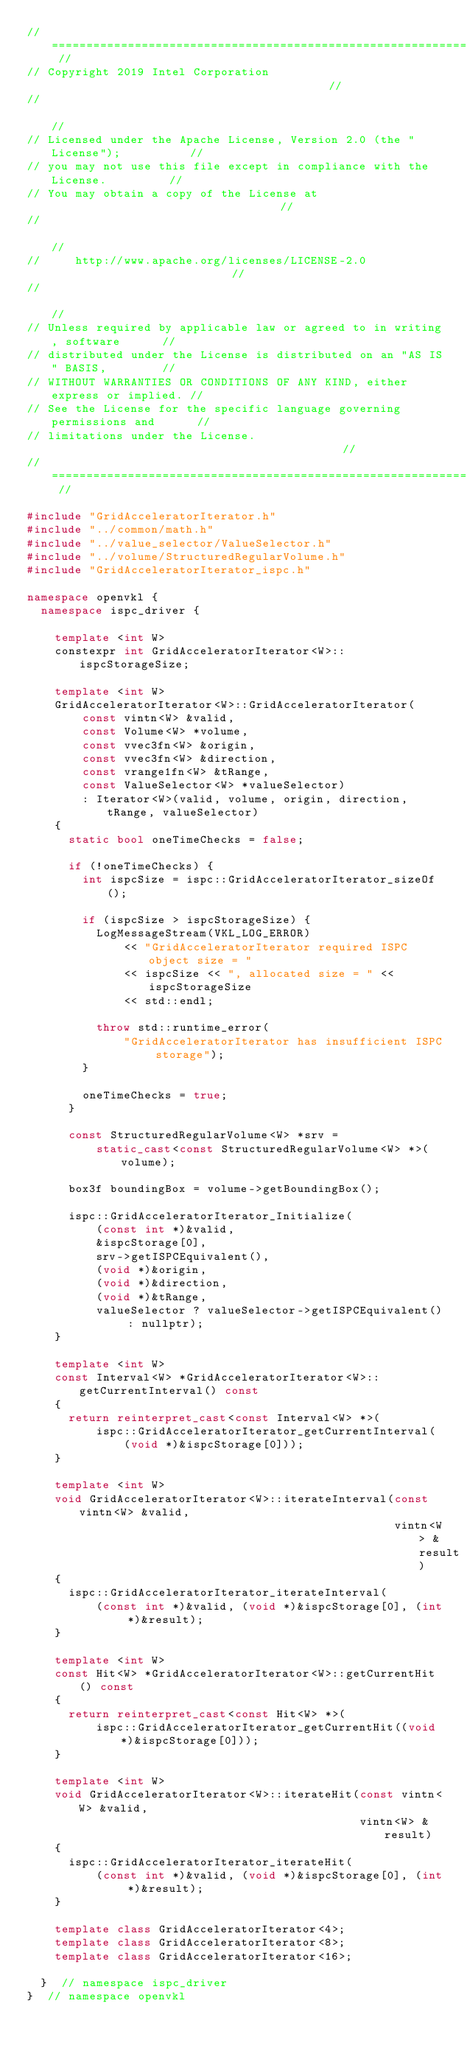<code> <loc_0><loc_0><loc_500><loc_500><_C++_>// ======================================================================== //
// Copyright 2019 Intel Corporation                                         //
//                                                                          //
// Licensed under the Apache License, Version 2.0 (the "License");          //
// you may not use this file except in compliance with the License.         //
// You may obtain a copy of the License at                                  //
//                                                                          //
//     http://www.apache.org/licenses/LICENSE-2.0                           //
//                                                                          //
// Unless required by applicable law or agreed to in writing, software      //
// distributed under the License is distributed on an "AS IS" BASIS,        //
// WITHOUT WARRANTIES OR CONDITIONS OF ANY KIND, either express or implied. //
// See the License for the specific language governing permissions and      //
// limitations under the License.                                           //
// ======================================================================== //

#include "GridAcceleratorIterator.h"
#include "../common/math.h"
#include "../value_selector/ValueSelector.h"
#include "../volume/StructuredRegularVolume.h"
#include "GridAcceleratorIterator_ispc.h"

namespace openvkl {
  namespace ispc_driver {

    template <int W>
    constexpr int GridAcceleratorIterator<W>::ispcStorageSize;

    template <int W>
    GridAcceleratorIterator<W>::GridAcceleratorIterator(
        const vintn<W> &valid,
        const Volume<W> *volume,
        const vvec3fn<W> &origin,
        const vvec3fn<W> &direction,
        const vrange1fn<W> &tRange,
        const ValueSelector<W> *valueSelector)
        : Iterator<W>(valid, volume, origin, direction, tRange, valueSelector)
    {
      static bool oneTimeChecks = false;

      if (!oneTimeChecks) {
        int ispcSize = ispc::GridAcceleratorIterator_sizeOf();

        if (ispcSize > ispcStorageSize) {
          LogMessageStream(VKL_LOG_ERROR)
              << "GridAcceleratorIterator required ISPC object size = "
              << ispcSize << ", allocated size = " << ispcStorageSize
              << std::endl;

          throw std::runtime_error(
              "GridAcceleratorIterator has insufficient ISPC storage");
        }

        oneTimeChecks = true;
      }

      const StructuredRegularVolume<W> *srv =
          static_cast<const StructuredRegularVolume<W> *>(volume);

      box3f boundingBox = volume->getBoundingBox();

      ispc::GridAcceleratorIterator_Initialize(
          (const int *)&valid,
          &ispcStorage[0],
          srv->getISPCEquivalent(),
          (void *)&origin,
          (void *)&direction,
          (void *)&tRange,
          valueSelector ? valueSelector->getISPCEquivalent() : nullptr);
    }

    template <int W>
    const Interval<W> *GridAcceleratorIterator<W>::getCurrentInterval() const
    {
      return reinterpret_cast<const Interval<W> *>(
          ispc::GridAcceleratorIterator_getCurrentInterval(
              (void *)&ispcStorage[0]));
    }

    template <int W>
    void GridAcceleratorIterator<W>::iterateInterval(const vintn<W> &valid,
                                                     vintn<W> &result)
    {
      ispc::GridAcceleratorIterator_iterateInterval(
          (const int *)&valid, (void *)&ispcStorage[0], (int *)&result);
    }

    template <int W>
    const Hit<W> *GridAcceleratorIterator<W>::getCurrentHit() const
    {
      return reinterpret_cast<const Hit<W> *>(
          ispc::GridAcceleratorIterator_getCurrentHit((void *)&ispcStorage[0]));
    }

    template <int W>
    void GridAcceleratorIterator<W>::iterateHit(const vintn<W> &valid,
                                                vintn<W> &result)
    {
      ispc::GridAcceleratorIterator_iterateHit(
          (const int *)&valid, (void *)&ispcStorage[0], (int *)&result);
    }

    template class GridAcceleratorIterator<4>;
    template class GridAcceleratorIterator<8>;
    template class GridAcceleratorIterator<16>;

  }  // namespace ispc_driver
}  // namespace openvkl
</code> 